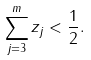<formula> <loc_0><loc_0><loc_500><loc_500>\sum _ { j = 3 } ^ { m } z _ { j } < \frac { 1 } { 2 } .</formula> 